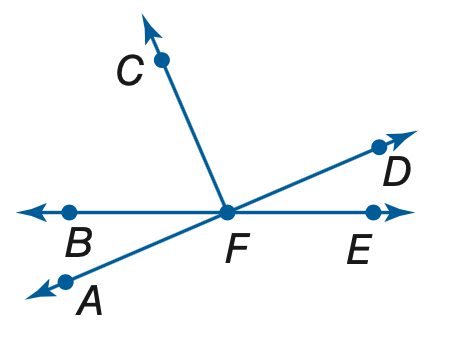Answer the mathemtical geometry problem and directly provide the correct option letter.
Question: If m \angle A F B = 8 x - 6 and m \angle B F C = 14 x + 8, find the value of x so that \angle A F C is a right angle.
Choices: A: 2 B: 3 C: 4 D: 5 C 